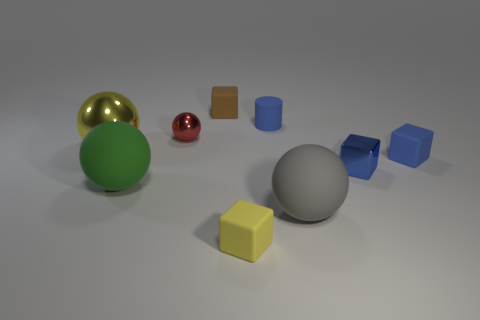The matte object that is the same color as the large metallic thing is what shape?
Give a very brief answer. Cube. What is the shape of the green matte thing?
Provide a short and direct response. Sphere. Are there fewer metallic spheres on the right side of the red metal thing than green shiny things?
Ensure brevity in your answer.  No. Are there any big blue objects of the same shape as the big green rubber thing?
Offer a terse response. No. The brown thing that is the same size as the cylinder is what shape?
Your answer should be compact. Cube. What number of objects are either big gray cylinders or green matte objects?
Provide a succinct answer. 1. Are there any tiny cyan matte spheres?
Your answer should be compact. No. Is the number of large rubber objects less than the number of red objects?
Ensure brevity in your answer.  No. Is there a yellow object that has the same size as the green thing?
Provide a short and direct response. Yes. There is a tiny brown rubber thing; is it the same shape as the tiny blue rubber thing in front of the red metallic thing?
Your answer should be compact. Yes. 